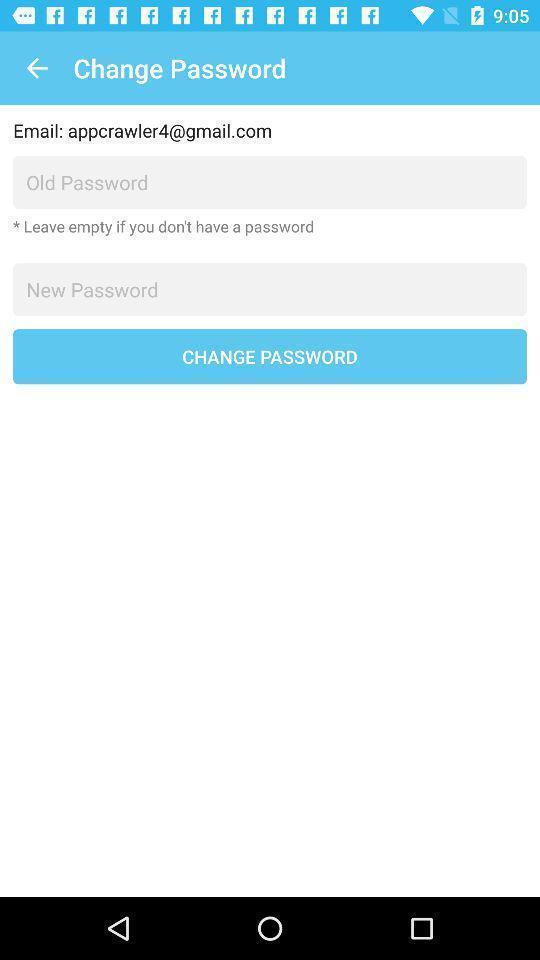Provide a detailed account of this screenshot. Page with option to change the password with old password. 